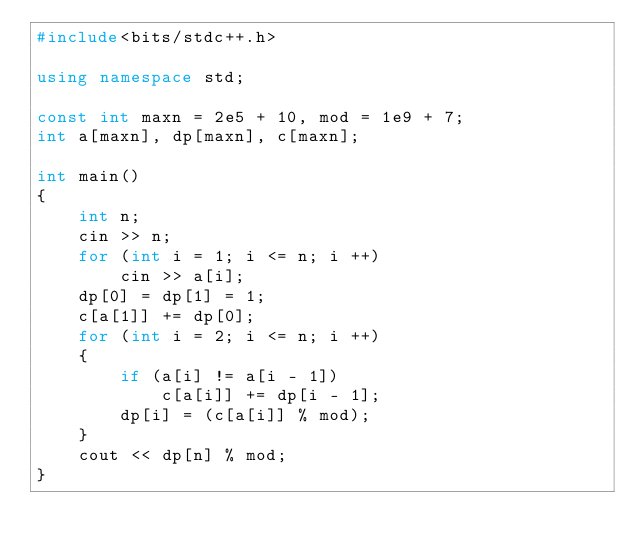Convert code to text. <code><loc_0><loc_0><loc_500><loc_500><_C++_>#include<bits/stdc++.h>

using namespace std;

const int maxn = 2e5 + 10, mod = 1e9 + 7;
int a[maxn], dp[maxn], c[maxn];

int main()
{
	int n;
    cin >> n;
    for (int i = 1; i <= n; i ++)
        cin >> a[i];
    dp[0] = dp[1] = 1;
    c[a[1]] += dp[0];
    for (int i = 2; i <= n; i ++)
    {
        if (a[i] != a[i - 1])
            c[a[i]] += dp[i - 1];
        dp[i] = (c[a[i]] % mod);
    }
    cout << dp[n] % mod;
}
</code> 